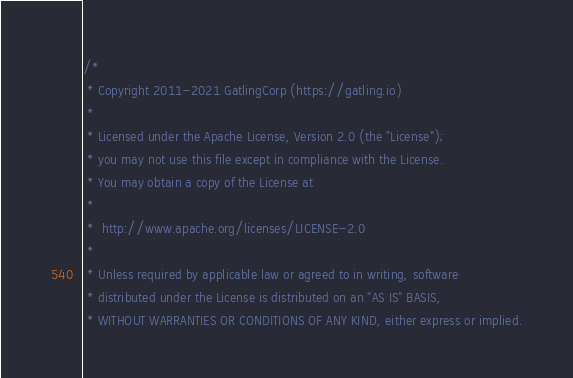Convert code to text. <code><loc_0><loc_0><loc_500><loc_500><_Scala_>/*
 * Copyright 2011-2021 GatlingCorp (https://gatling.io)
 *
 * Licensed under the Apache License, Version 2.0 (the "License");
 * you may not use this file except in compliance with the License.
 * You may obtain a copy of the License at
 *
 *  http://www.apache.org/licenses/LICENSE-2.0
 *
 * Unless required by applicable law or agreed to in writing, software
 * distributed under the License is distributed on an "AS IS" BASIS,
 * WITHOUT WARRANTIES OR CONDITIONS OF ANY KIND, either express or implied.</code> 